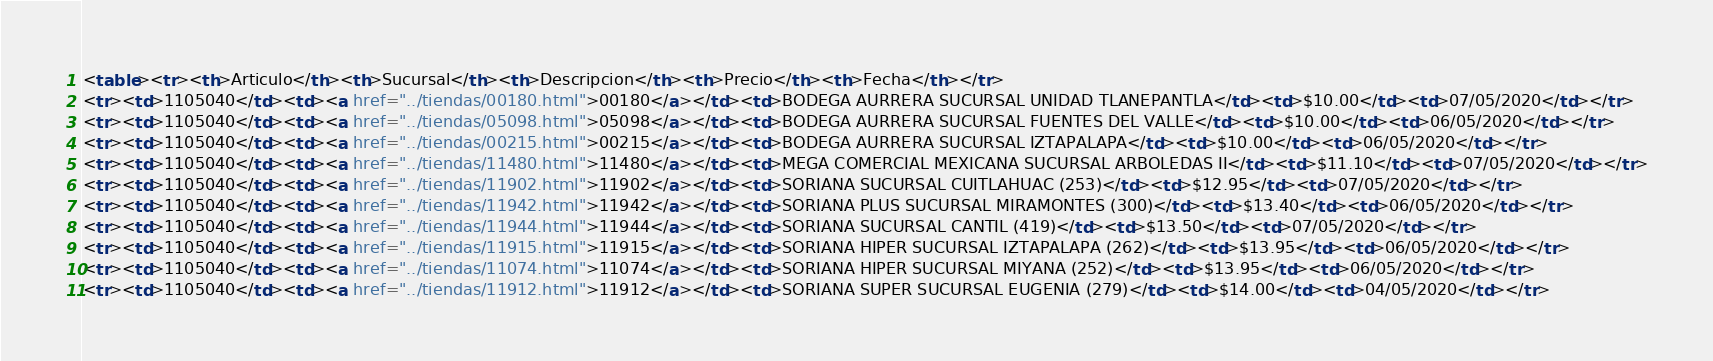<code> <loc_0><loc_0><loc_500><loc_500><_HTML_><table><tr><th>Articulo</th><th>Sucursal</th><th>Descripcion</th><th>Precio</th><th>Fecha</th></tr>
<tr><td>1105040</td><td><a href="../tiendas/00180.html">00180</a></td><td>BODEGA AURRERA SUCURSAL UNIDAD TLANEPANTLA</td><td>$10.00</td><td>07/05/2020</td></tr>
<tr><td>1105040</td><td><a href="../tiendas/05098.html">05098</a></td><td>BODEGA AURRERA SUCURSAL FUENTES DEL VALLE</td><td>$10.00</td><td>06/05/2020</td></tr>
<tr><td>1105040</td><td><a href="../tiendas/00215.html">00215</a></td><td>BODEGA AURRERA SUCURSAL IZTAPALAPA</td><td>$10.00</td><td>06/05/2020</td></tr>
<tr><td>1105040</td><td><a href="../tiendas/11480.html">11480</a></td><td>MEGA COMERCIAL MEXICANA SUCURSAL ARBOLEDAS II</td><td>$11.10</td><td>07/05/2020</td></tr>
<tr><td>1105040</td><td><a href="../tiendas/11902.html">11902</a></td><td>SORIANA SUCURSAL CUITLAHUAC (253)</td><td>$12.95</td><td>07/05/2020</td></tr>
<tr><td>1105040</td><td><a href="../tiendas/11942.html">11942</a></td><td>SORIANA PLUS SUCURSAL MIRAMONTES (300)</td><td>$13.40</td><td>06/05/2020</td></tr>
<tr><td>1105040</td><td><a href="../tiendas/11944.html">11944</a></td><td>SORIANA SUCURSAL CANTIL (419)</td><td>$13.50</td><td>07/05/2020</td></tr>
<tr><td>1105040</td><td><a href="../tiendas/11915.html">11915</a></td><td>SORIANA HIPER SUCURSAL IZTAPALAPA (262)</td><td>$13.95</td><td>06/05/2020</td></tr>
<tr><td>1105040</td><td><a href="../tiendas/11074.html">11074</a></td><td>SORIANA HIPER SUCURSAL MIYANA (252)</td><td>$13.95</td><td>06/05/2020</td></tr>
<tr><td>1105040</td><td><a href="../tiendas/11912.html">11912</a></td><td>SORIANA SUPER SUCURSAL EUGENIA (279)</td><td>$14.00</td><td>04/05/2020</td></tr></code> 